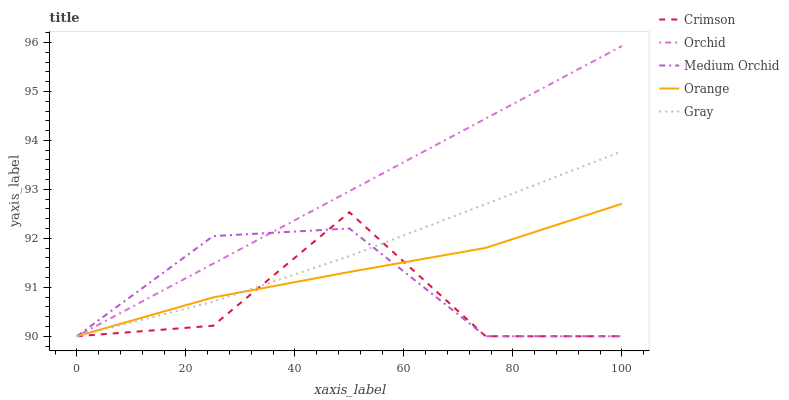Does Orange have the minimum area under the curve?
Answer yes or no. No. Does Orange have the maximum area under the curve?
Answer yes or no. No. Is Orange the smoothest?
Answer yes or no. No. Is Orange the roughest?
Answer yes or no. No. Does Orange have the highest value?
Answer yes or no. No. 